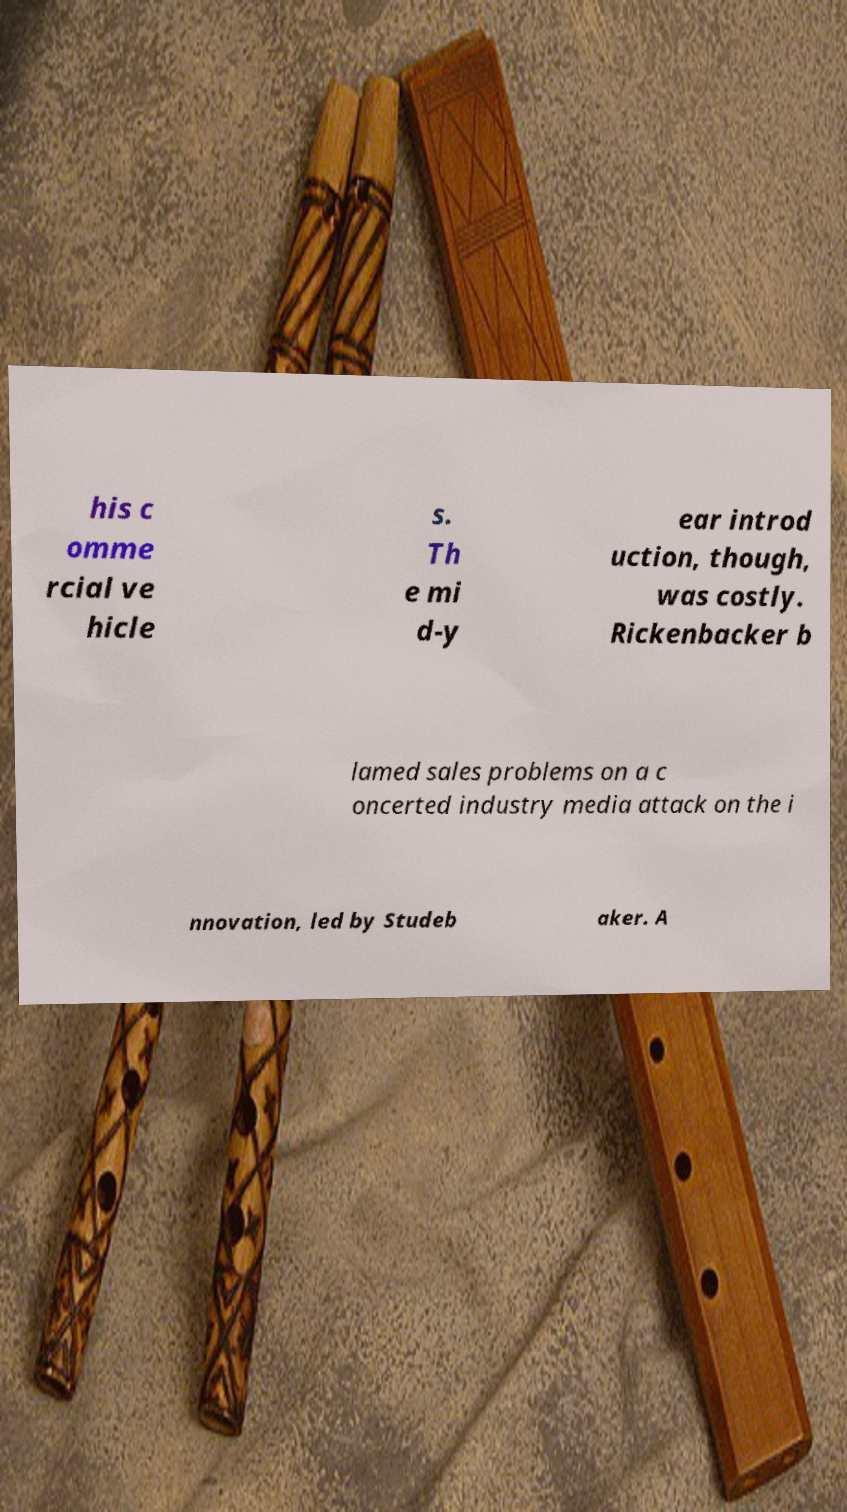I need the written content from this picture converted into text. Can you do that? his c omme rcial ve hicle s. Th e mi d-y ear introd uction, though, was costly. Rickenbacker b lamed sales problems on a c oncerted industry media attack on the i nnovation, led by Studeb aker. A 